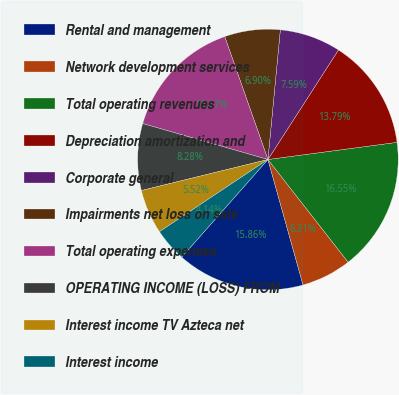<chart> <loc_0><loc_0><loc_500><loc_500><pie_chart><fcel>Rental and management<fcel>Network development services<fcel>Total operating revenues<fcel>Depreciation amortization and<fcel>Corporate general<fcel>Impairments net loss on sale<fcel>Total operating expenses<fcel>OPERATING INCOME (LOSS) FROM<fcel>Interest income TV Azteca net<fcel>Interest income<nl><fcel>15.86%<fcel>6.21%<fcel>16.55%<fcel>13.79%<fcel>7.59%<fcel>6.9%<fcel>15.17%<fcel>8.28%<fcel>5.52%<fcel>4.14%<nl></chart> 